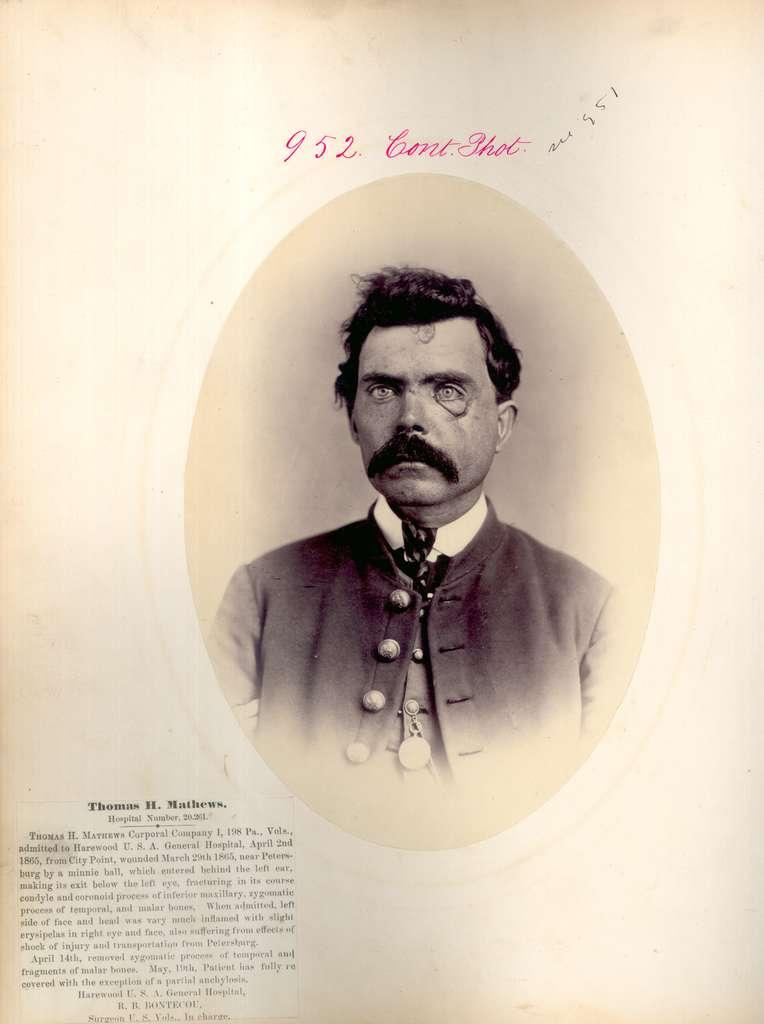What is present on the paper in the image? The paper contains an image of a man. What else can be found on the paper besides the image? There is text on the paper. What direction is the van traveling in the image? There is no van present in the image; it only contains a paper with an image of a man and text. 